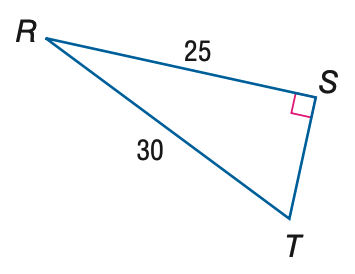Answer the mathemtical geometry problem and directly provide the correct option letter.
Question: Find the measure of \angle T to the nearest tenth.
Choices: A: 33.6 B: 39.8 C: 50.2 D: 56.4 D 